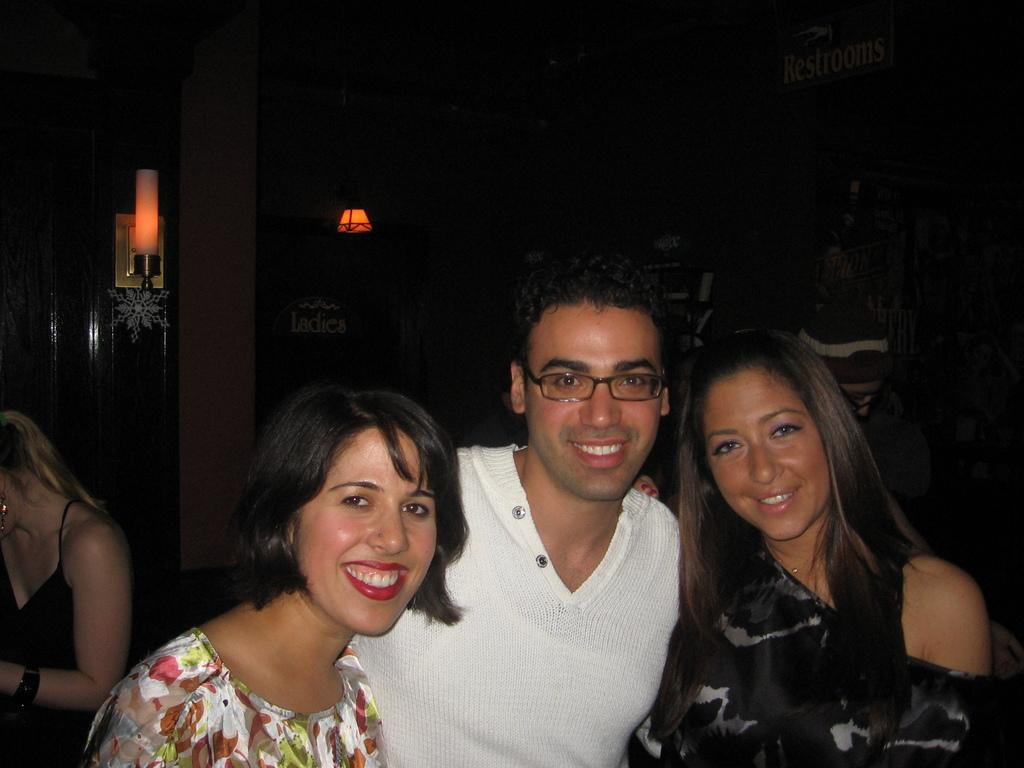Who is present in the image? There is a man and two women in the image. What is the man doing in the image? The man is standing in the image. How are the women depicted in the image? The women are smiling in the image. What is the man wearing in the image? The man is wearing a white dress in the image. How many mice can be seen running around the man's feet in the image? There are no mice present in the image. What type of dust is visible on the women's clothing in the image? There is no dust visible on the women's clothing in the image. 